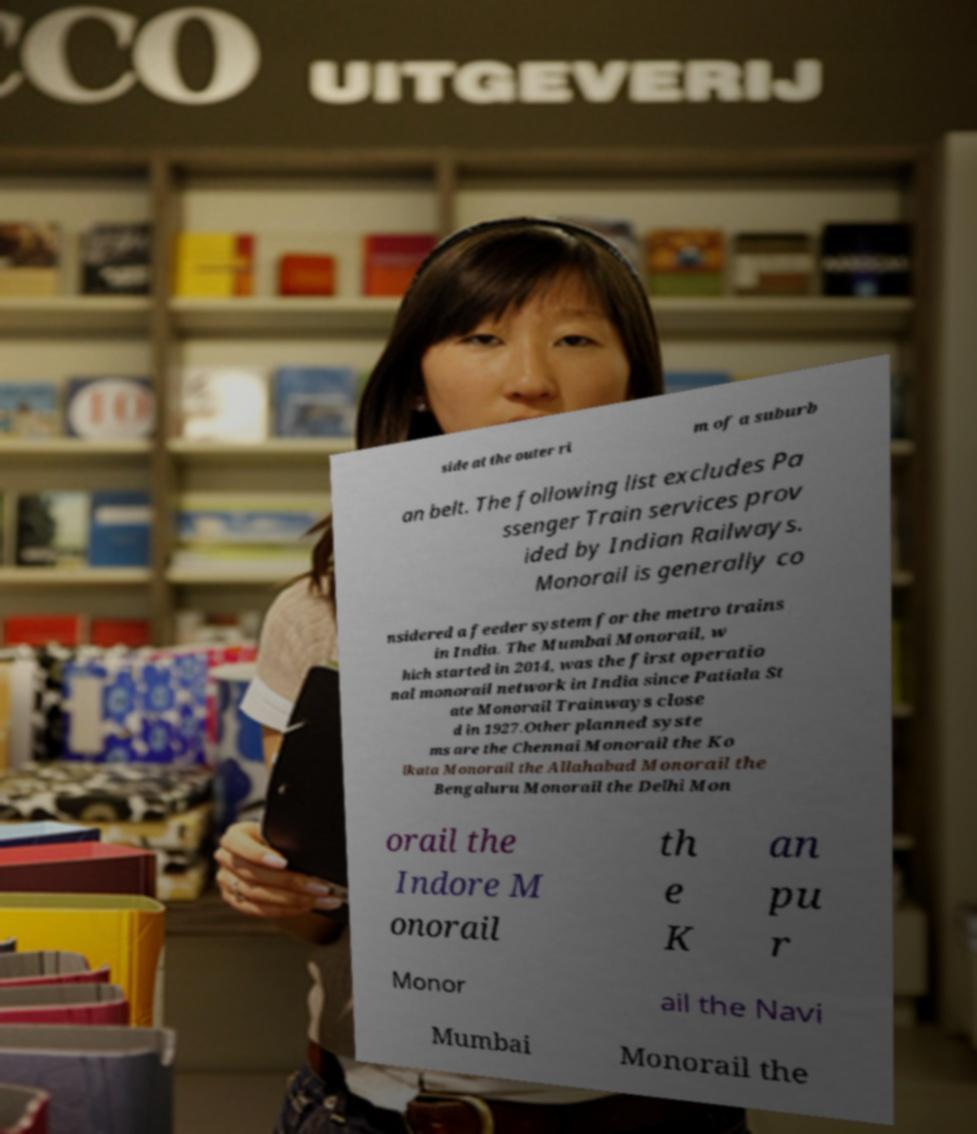There's text embedded in this image that I need extracted. Can you transcribe it verbatim? side at the outer ri m of a suburb an belt. The following list excludes Pa ssenger Train services prov ided by Indian Railways. Monorail is generally co nsidered a feeder system for the metro trains in India. The Mumbai Monorail, w hich started in 2014, was the first operatio nal monorail network in India since Patiala St ate Monorail Trainways close d in 1927.Other planned syste ms are the Chennai Monorail the Ko lkata Monorail the Allahabad Monorail the Bengaluru Monorail the Delhi Mon orail the Indore M onorail th e K an pu r Monor ail the Navi Mumbai Monorail the 